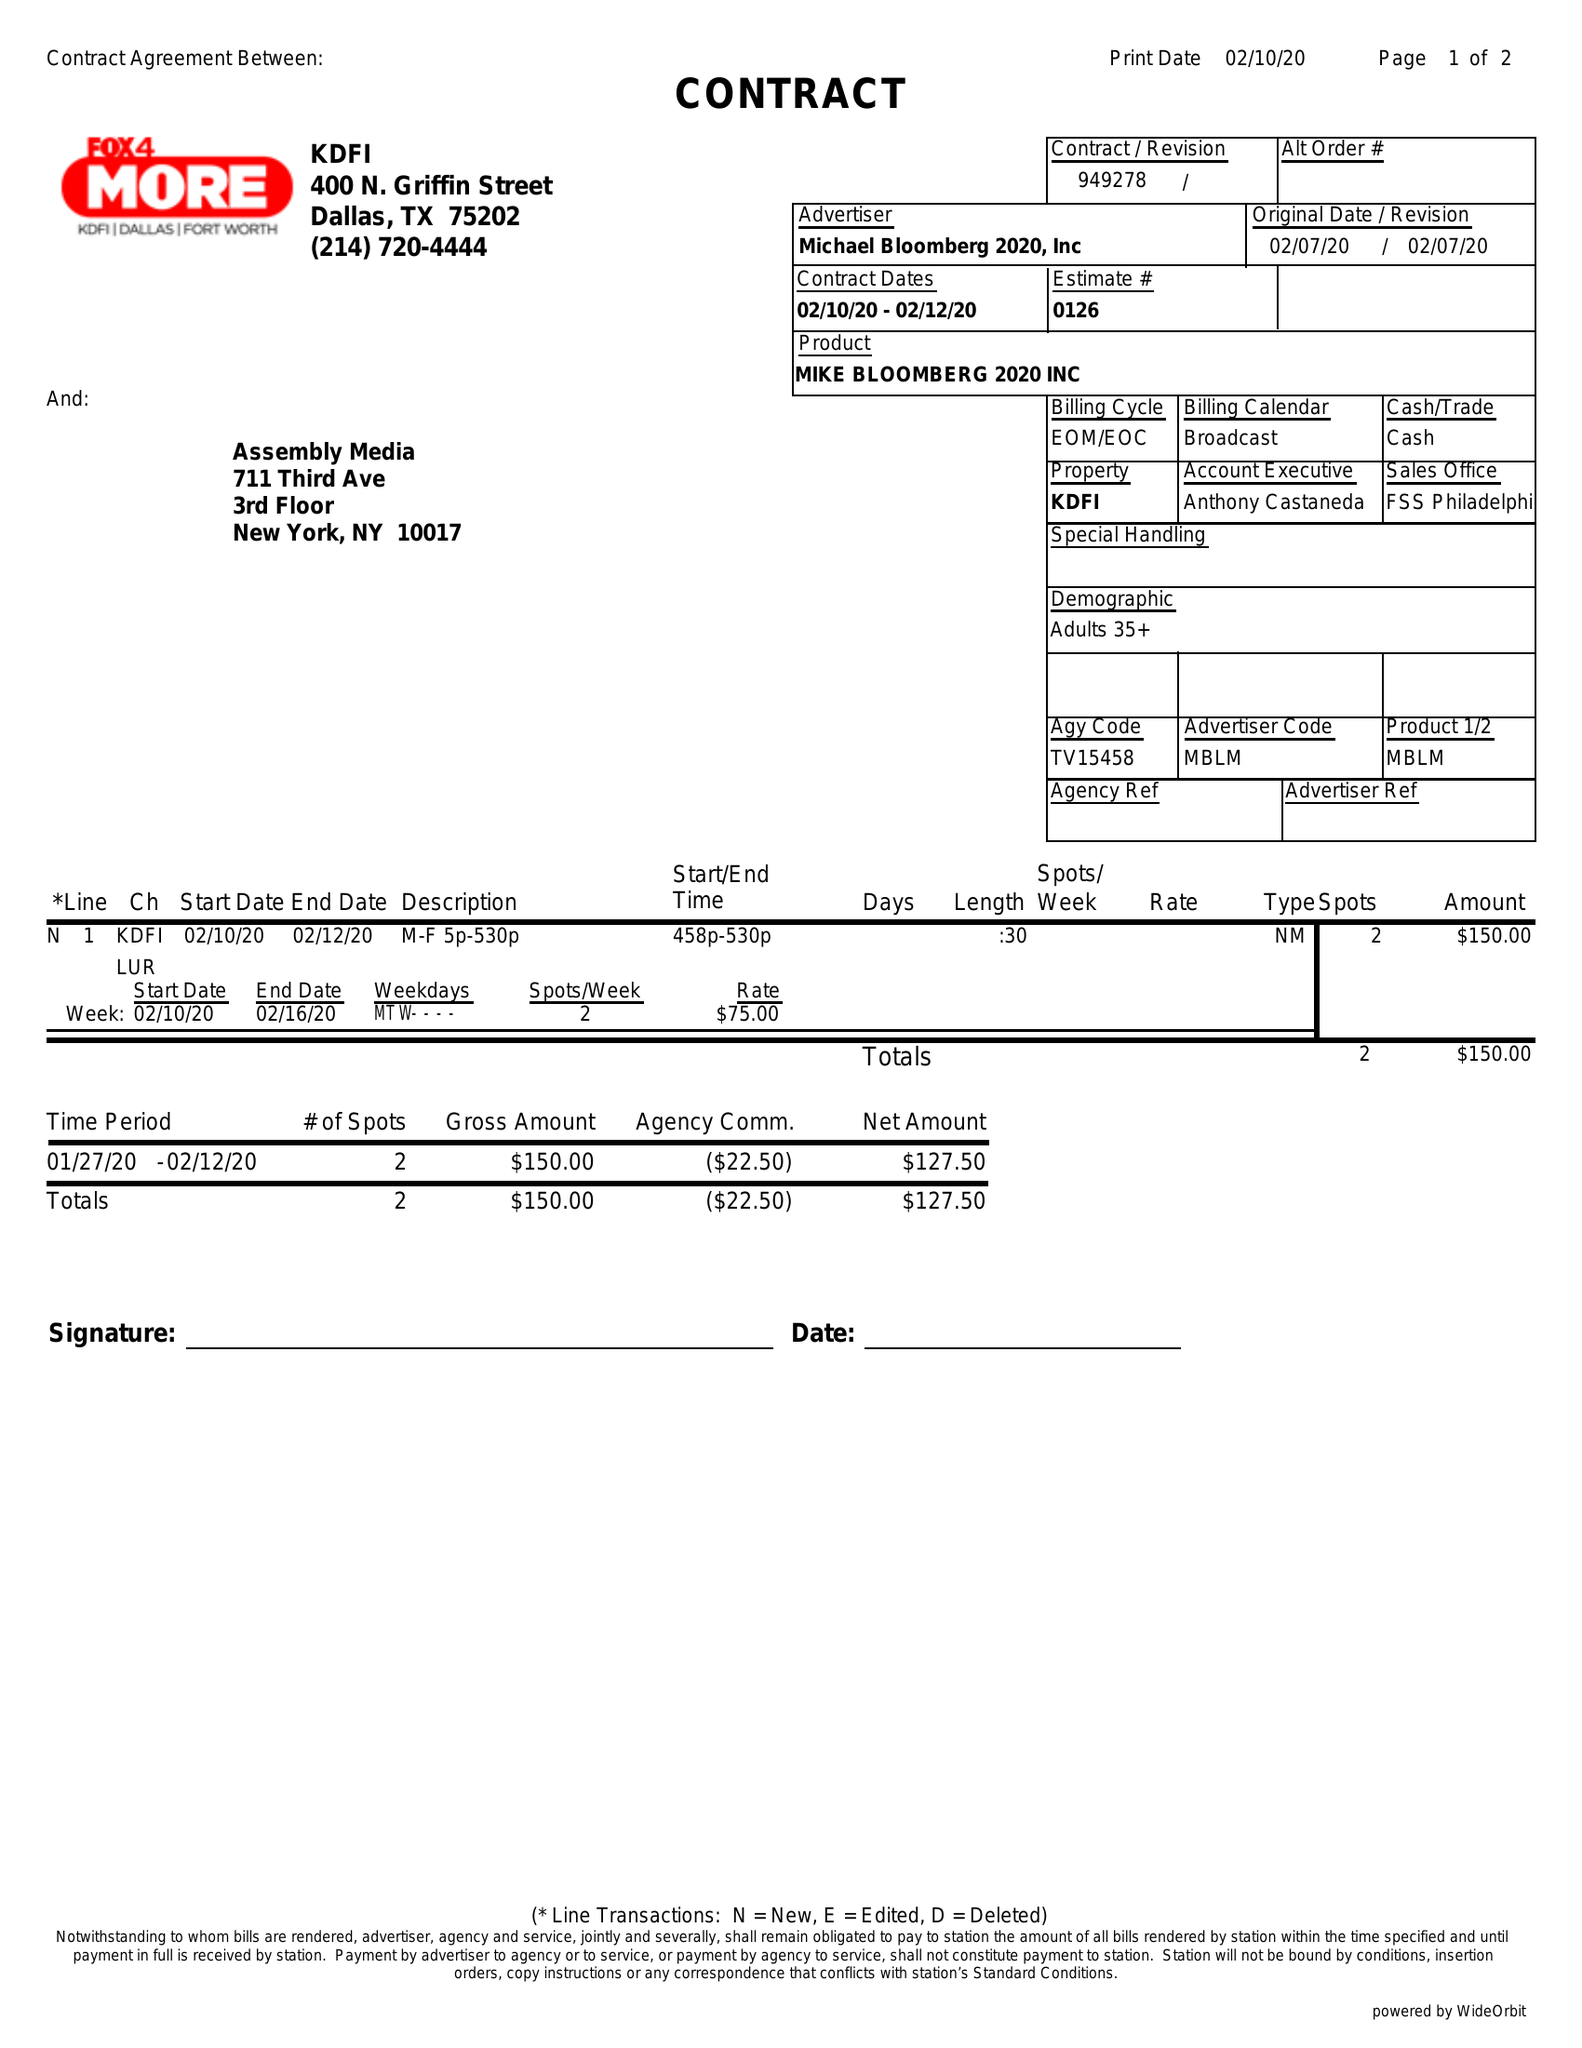What is the value for the contract_num?
Answer the question using a single word or phrase. 949278 